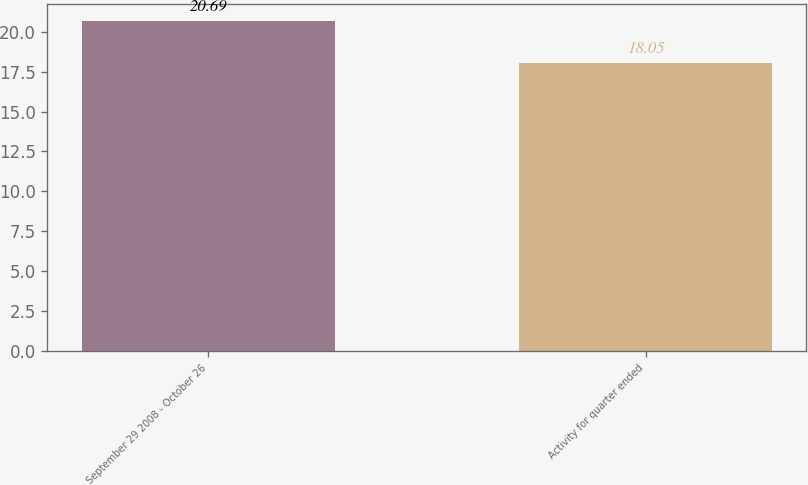Convert chart. <chart><loc_0><loc_0><loc_500><loc_500><bar_chart><fcel>September 29 2008 - October 26<fcel>Activity for quarter ended<nl><fcel>20.69<fcel>18.05<nl></chart> 